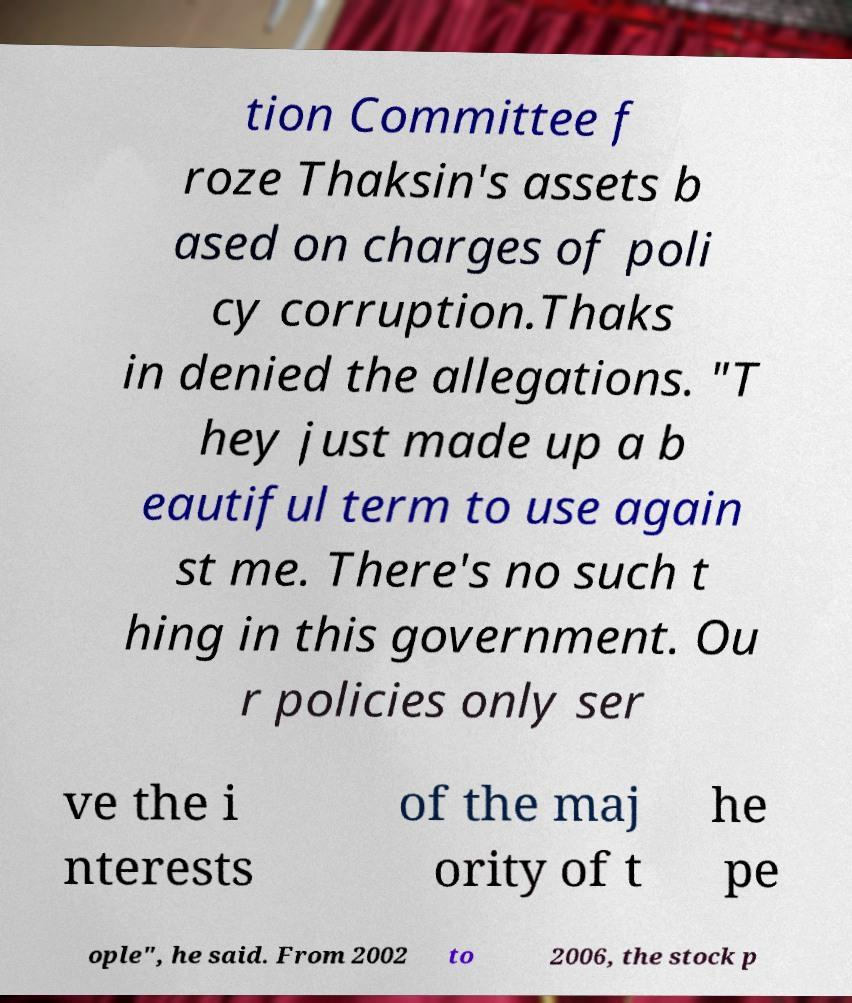Could you extract and type out the text from this image? tion Committee f roze Thaksin's assets b ased on charges of poli cy corruption.Thaks in denied the allegations. "T hey just made up a b eautiful term to use again st me. There's no such t hing in this government. Ou r policies only ser ve the i nterests of the maj ority of t he pe ople", he said. From 2002 to 2006, the stock p 